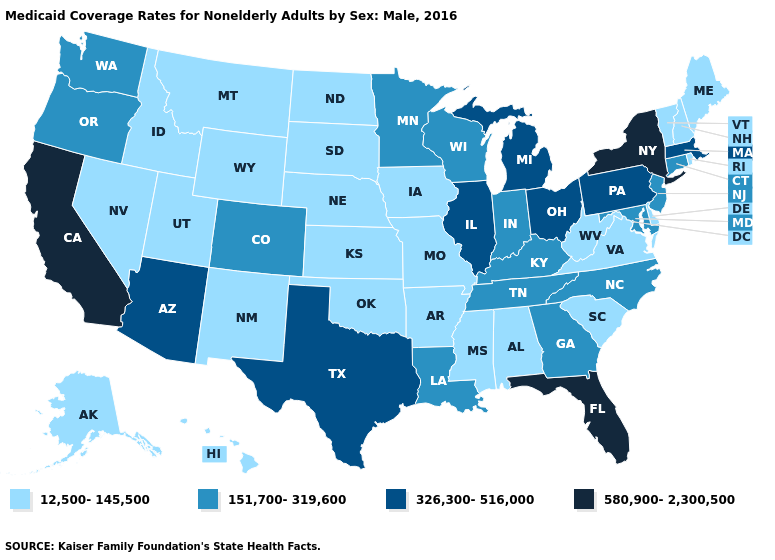Name the states that have a value in the range 151,700-319,600?
Be succinct. Colorado, Connecticut, Georgia, Indiana, Kentucky, Louisiana, Maryland, Minnesota, New Jersey, North Carolina, Oregon, Tennessee, Washington, Wisconsin. Does Michigan have a lower value than California?
Write a very short answer. Yes. Does Michigan have a lower value than Florida?
Concise answer only. Yes. Is the legend a continuous bar?
Answer briefly. No. Does Oklahoma have the same value as California?
Short answer required. No. Does Idaho have the lowest value in the USA?
Give a very brief answer. Yes. What is the value of Illinois?
Quick response, please. 326,300-516,000. Does California have the highest value in the West?
Give a very brief answer. Yes. Name the states that have a value in the range 326,300-516,000?
Answer briefly. Arizona, Illinois, Massachusetts, Michigan, Ohio, Pennsylvania, Texas. Name the states that have a value in the range 12,500-145,500?
Quick response, please. Alabama, Alaska, Arkansas, Delaware, Hawaii, Idaho, Iowa, Kansas, Maine, Mississippi, Missouri, Montana, Nebraska, Nevada, New Hampshire, New Mexico, North Dakota, Oklahoma, Rhode Island, South Carolina, South Dakota, Utah, Vermont, Virginia, West Virginia, Wyoming. Name the states that have a value in the range 151,700-319,600?
Quick response, please. Colorado, Connecticut, Georgia, Indiana, Kentucky, Louisiana, Maryland, Minnesota, New Jersey, North Carolina, Oregon, Tennessee, Washington, Wisconsin. Does Connecticut have a lower value than Arizona?
Give a very brief answer. Yes. Name the states that have a value in the range 12,500-145,500?
Answer briefly. Alabama, Alaska, Arkansas, Delaware, Hawaii, Idaho, Iowa, Kansas, Maine, Mississippi, Missouri, Montana, Nebraska, Nevada, New Hampshire, New Mexico, North Dakota, Oklahoma, Rhode Island, South Carolina, South Dakota, Utah, Vermont, Virginia, West Virginia, Wyoming. Name the states that have a value in the range 580,900-2,300,500?
Give a very brief answer. California, Florida, New York. What is the lowest value in states that border South Dakota?
Give a very brief answer. 12,500-145,500. 